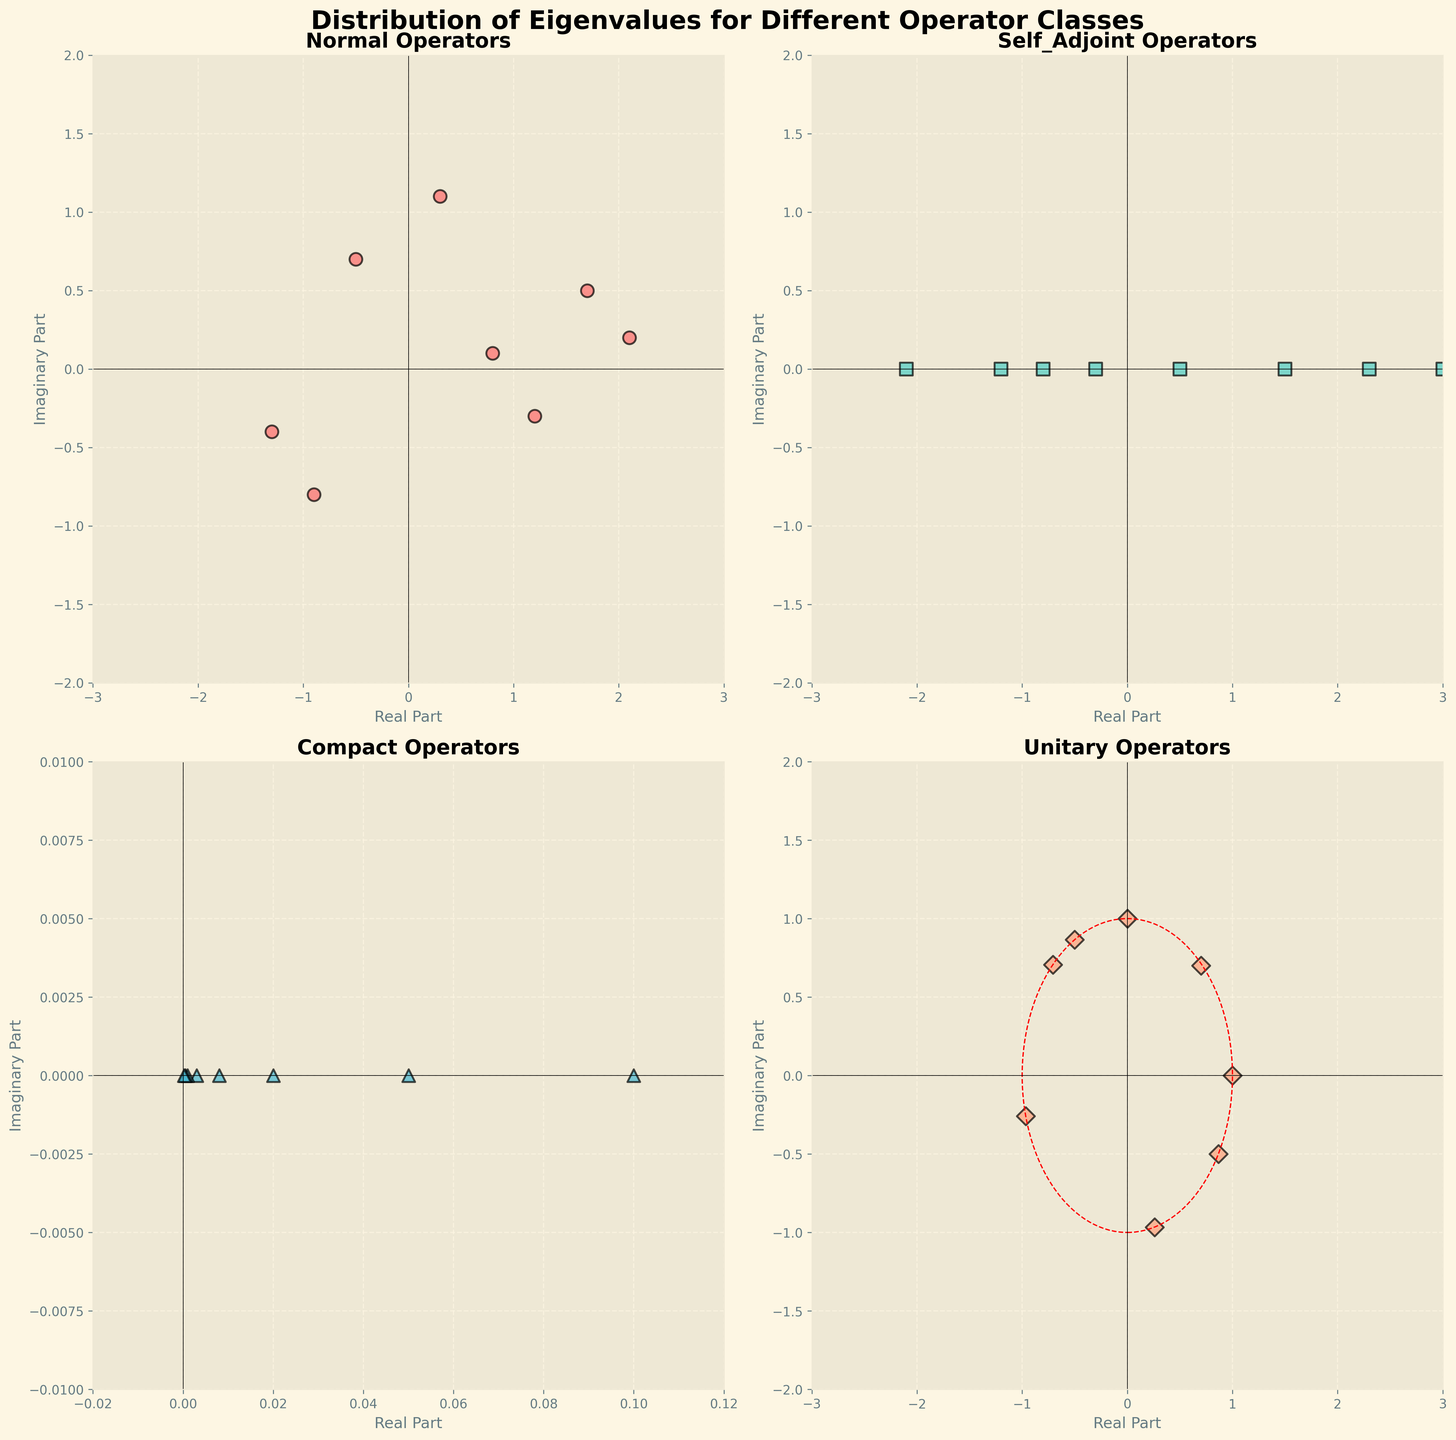What's the general positioning of eigenvalues for Self-Adjoint operators? In Self-Adjoint operators, based on their characteristic properties, the eigenvalues are always real. From the graph, this property is verified by observing that all eigenvalues have an imaginary part of zero and are positioned along the real axis.
Answer: Along the real axis Which operator class has eigenvalues that lie close to the unit circle in the complex plane? Since Unitary operators have eigenvalues that lie on the unit circle in the complex plane due to their spectral properties, we should observe the unit circle plotted in the corresponding subplot. The eigenvalues are clearly clustered around or on this circle, validating this property.
Answer: Unitary What is the average imaginary part of the Normal operator class's eigenvalues? To calculate this, sum the imaginary parts of the Normal class eigenvalues (0.1 + (-0.3) + 0.7 + 0.2 + (-0.4) + 1.1 + (-0.8) + 0.5) = 1.1. As there are 8 data points, the average is 1.1 / 8 = 0.1375.
Answer: 0.1375 Compare the spread of eigenvalues in the Complex and Normal operator classes. Which class appears to have a wider range of values? Normal eigenvalues are scattered in a larger region both in real and imaginary parts as compared to Compact eigenvalues which are tightly packed near the origin. Observing this distribution clearly shows that Normal operators have wider ranges.
Answer: Normal What can be inferred about the real part of eigenvalues for Compact operators? Compact operators have eigenvalues that tend to accumulate at zero. This is clearly observable from the narrow range of real parts (0.1 to 0.0002) in the subplot, confirming the accumulation property.
Answer: They tend to accumulate near zero Which operator class has the most variation in the real parts of their eigenvalues? The subplot for the Self-Adjoint operators shows the greatest spread in the real parts, ranging from -2.1 to 3, indicating a wide variation compared to other operator classes.
Answer: Self-Adjoint Do any of the operator classes have eigenvalues that are purely imaginary or purely real? Both Self-Adjoint and Compact has eigenvalues that are purely real as shown in their respective subplots where the imaginary component is zero. Unitary operators, however, do have a purely real eigenvalue (1) and a purely imaginary eigenvalue (0,1).
Answer: Self-Adjoint and Compact (purely real), Unitary (one purely real and one purely imaginary) Which operator class shows symmetry in the distribution of eigenvalues around the origin? By visual inspection, the subplot for Unitary operators shows symmetrical scatter around the origin indicating their symmetric properties characteristic of Unitary matrices.
Answer: Unitary Are there any eigenvalues with both real and imaginary parts equal to zero? If so, in which operator class(es) do they appear? From all the subplots, there is no eigenvalue point exactly at the origin (0,0); thus, no class has eigenvalues with both components exactly zero.
Answer: None 